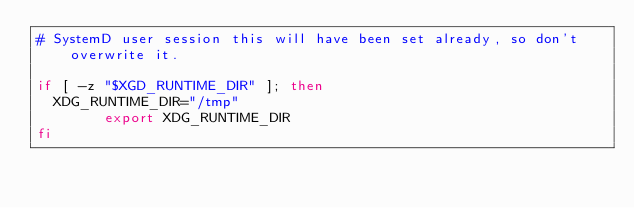Convert code to text. <code><loc_0><loc_0><loc_500><loc_500><_Bash_># SystemD user session this will have been set already, so don't overwrite it.

if [ -z "$XGD_RUNTIME_DIR" ]; then
	XDG_RUNTIME_DIR="/tmp"
        export XDG_RUNTIME_DIR
fi
</code> 